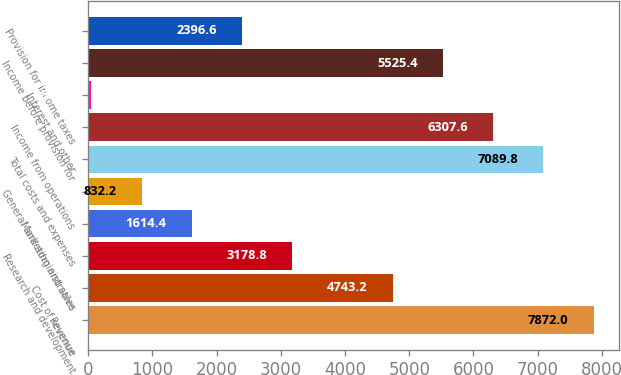Convert chart to OTSL. <chart><loc_0><loc_0><loc_500><loc_500><bar_chart><fcel>Revenue<fcel>Cost of revenue<fcel>Research and development<fcel>Marketing and sales<fcel>General and administrative<fcel>Total costs and expenses<fcel>Income from operations<fcel>Interest and other<fcel>Income before provision for<fcel>Provision for income taxes<nl><fcel>7872<fcel>4743.2<fcel>3178.8<fcel>1614.4<fcel>832.2<fcel>7089.8<fcel>6307.6<fcel>50<fcel>5525.4<fcel>2396.6<nl></chart> 